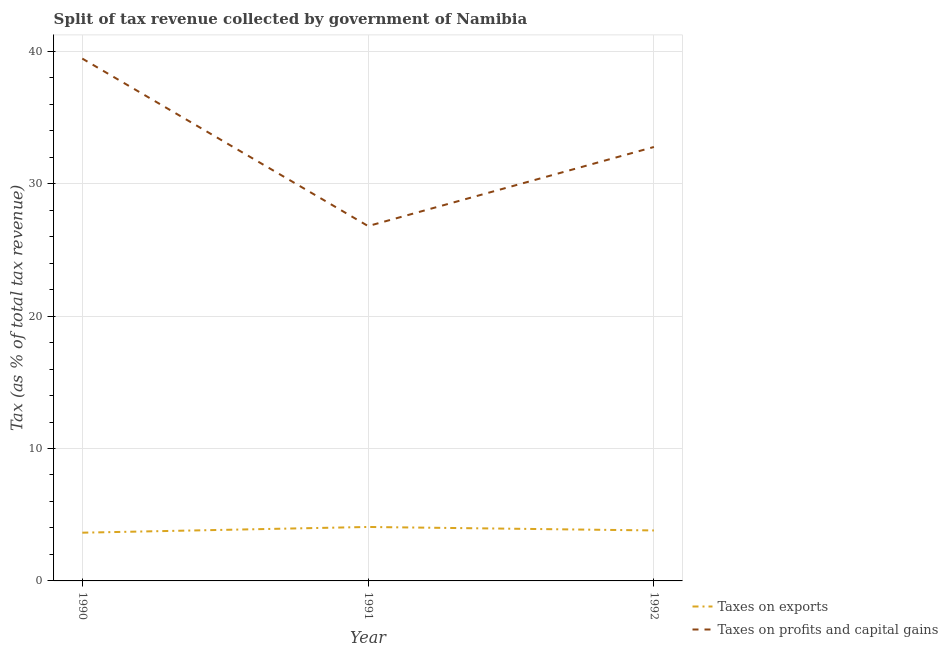How many different coloured lines are there?
Give a very brief answer. 2. Does the line corresponding to percentage of revenue obtained from taxes on profits and capital gains intersect with the line corresponding to percentage of revenue obtained from taxes on exports?
Ensure brevity in your answer.  No. Is the number of lines equal to the number of legend labels?
Provide a short and direct response. Yes. What is the percentage of revenue obtained from taxes on exports in 1992?
Your answer should be very brief. 3.81. Across all years, what is the maximum percentage of revenue obtained from taxes on exports?
Ensure brevity in your answer.  4.07. Across all years, what is the minimum percentage of revenue obtained from taxes on profits and capital gains?
Ensure brevity in your answer.  26.8. What is the total percentage of revenue obtained from taxes on exports in the graph?
Your answer should be compact. 11.53. What is the difference between the percentage of revenue obtained from taxes on profits and capital gains in 1990 and that in 1991?
Your response must be concise. 12.65. What is the difference between the percentage of revenue obtained from taxes on profits and capital gains in 1992 and the percentage of revenue obtained from taxes on exports in 1990?
Your answer should be very brief. 29.13. What is the average percentage of revenue obtained from taxes on profits and capital gains per year?
Offer a terse response. 33. In the year 1990, what is the difference between the percentage of revenue obtained from taxes on exports and percentage of revenue obtained from taxes on profits and capital gains?
Provide a succinct answer. -35.8. What is the ratio of the percentage of revenue obtained from taxes on profits and capital gains in 1990 to that in 1992?
Your answer should be very brief. 1.2. Is the percentage of revenue obtained from taxes on profits and capital gains in 1991 less than that in 1992?
Offer a very short reply. Yes. What is the difference between the highest and the second highest percentage of revenue obtained from taxes on exports?
Give a very brief answer. 0.26. What is the difference between the highest and the lowest percentage of revenue obtained from taxes on exports?
Provide a succinct answer. 0.43. Does the percentage of revenue obtained from taxes on profits and capital gains monotonically increase over the years?
Your response must be concise. No. Is the percentage of revenue obtained from taxes on profits and capital gains strictly less than the percentage of revenue obtained from taxes on exports over the years?
Your response must be concise. No. How many lines are there?
Give a very brief answer. 2. How many years are there in the graph?
Give a very brief answer. 3. What is the difference between two consecutive major ticks on the Y-axis?
Offer a very short reply. 10. Does the graph contain any zero values?
Keep it short and to the point. No. How many legend labels are there?
Your answer should be compact. 2. How are the legend labels stacked?
Your answer should be very brief. Vertical. What is the title of the graph?
Offer a very short reply. Split of tax revenue collected by government of Namibia. Does "Number of arrivals" appear as one of the legend labels in the graph?
Give a very brief answer. No. What is the label or title of the X-axis?
Offer a terse response. Year. What is the label or title of the Y-axis?
Offer a very short reply. Tax (as % of total tax revenue). What is the Tax (as % of total tax revenue) of Taxes on exports in 1990?
Your answer should be compact. 3.64. What is the Tax (as % of total tax revenue) of Taxes on profits and capital gains in 1990?
Ensure brevity in your answer.  39.45. What is the Tax (as % of total tax revenue) in Taxes on exports in 1991?
Keep it short and to the point. 4.07. What is the Tax (as % of total tax revenue) of Taxes on profits and capital gains in 1991?
Offer a very short reply. 26.8. What is the Tax (as % of total tax revenue) of Taxes on exports in 1992?
Your answer should be compact. 3.81. What is the Tax (as % of total tax revenue) in Taxes on profits and capital gains in 1992?
Give a very brief answer. 32.77. Across all years, what is the maximum Tax (as % of total tax revenue) of Taxes on exports?
Provide a succinct answer. 4.07. Across all years, what is the maximum Tax (as % of total tax revenue) of Taxes on profits and capital gains?
Provide a short and direct response. 39.45. Across all years, what is the minimum Tax (as % of total tax revenue) of Taxes on exports?
Your answer should be very brief. 3.64. Across all years, what is the minimum Tax (as % of total tax revenue) in Taxes on profits and capital gains?
Keep it short and to the point. 26.8. What is the total Tax (as % of total tax revenue) of Taxes on exports in the graph?
Your answer should be very brief. 11.53. What is the total Tax (as % of total tax revenue) in Taxes on profits and capital gains in the graph?
Provide a short and direct response. 99.01. What is the difference between the Tax (as % of total tax revenue) in Taxes on exports in 1990 and that in 1991?
Give a very brief answer. -0.43. What is the difference between the Tax (as % of total tax revenue) of Taxes on profits and capital gains in 1990 and that in 1991?
Your response must be concise. 12.65. What is the difference between the Tax (as % of total tax revenue) in Taxes on exports in 1990 and that in 1992?
Your answer should be compact. -0.17. What is the difference between the Tax (as % of total tax revenue) of Taxes on profits and capital gains in 1990 and that in 1992?
Your response must be concise. 6.68. What is the difference between the Tax (as % of total tax revenue) of Taxes on exports in 1991 and that in 1992?
Offer a very short reply. 0.26. What is the difference between the Tax (as % of total tax revenue) in Taxes on profits and capital gains in 1991 and that in 1992?
Make the answer very short. -5.97. What is the difference between the Tax (as % of total tax revenue) in Taxes on exports in 1990 and the Tax (as % of total tax revenue) in Taxes on profits and capital gains in 1991?
Offer a very short reply. -23.16. What is the difference between the Tax (as % of total tax revenue) of Taxes on exports in 1990 and the Tax (as % of total tax revenue) of Taxes on profits and capital gains in 1992?
Provide a succinct answer. -29.13. What is the difference between the Tax (as % of total tax revenue) in Taxes on exports in 1991 and the Tax (as % of total tax revenue) in Taxes on profits and capital gains in 1992?
Provide a succinct answer. -28.7. What is the average Tax (as % of total tax revenue) of Taxes on exports per year?
Your answer should be compact. 3.84. What is the average Tax (as % of total tax revenue) of Taxes on profits and capital gains per year?
Your answer should be compact. 33. In the year 1990, what is the difference between the Tax (as % of total tax revenue) in Taxes on exports and Tax (as % of total tax revenue) in Taxes on profits and capital gains?
Ensure brevity in your answer.  -35.8. In the year 1991, what is the difference between the Tax (as % of total tax revenue) in Taxes on exports and Tax (as % of total tax revenue) in Taxes on profits and capital gains?
Your response must be concise. -22.72. In the year 1992, what is the difference between the Tax (as % of total tax revenue) in Taxes on exports and Tax (as % of total tax revenue) in Taxes on profits and capital gains?
Ensure brevity in your answer.  -28.96. What is the ratio of the Tax (as % of total tax revenue) in Taxes on exports in 1990 to that in 1991?
Provide a succinct answer. 0.89. What is the ratio of the Tax (as % of total tax revenue) in Taxes on profits and capital gains in 1990 to that in 1991?
Offer a terse response. 1.47. What is the ratio of the Tax (as % of total tax revenue) in Taxes on exports in 1990 to that in 1992?
Your answer should be compact. 0.96. What is the ratio of the Tax (as % of total tax revenue) in Taxes on profits and capital gains in 1990 to that in 1992?
Your response must be concise. 1.2. What is the ratio of the Tax (as % of total tax revenue) of Taxes on exports in 1991 to that in 1992?
Your response must be concise. 1.07. What is the ratio of the Tax (as % of total tax revenue) in Taxes on profits and capital gains in 1991 to that in 1992?
Your response must be concise. 0.82. What is the difference between the highest and the second highest Tax (as % of total tax revenue) in Taxes on exports?
Give a very brief answer. 0.26. What is the difference between the highest and the second highest Tax (as % of total tax revenue) in Taxes on profits and capital gains?
Make the answer very short. 6.68. What is the difference between the highest and the lowest Tax (as % of total tax revenue) in Taxes on exports?
Offer a very short reply. 0.43. What is the difference between the highest and the lowest Tax (as % of total tax revenue) of Taxes on profits and capital gains?
Your answer should be very brief. 12.65. 